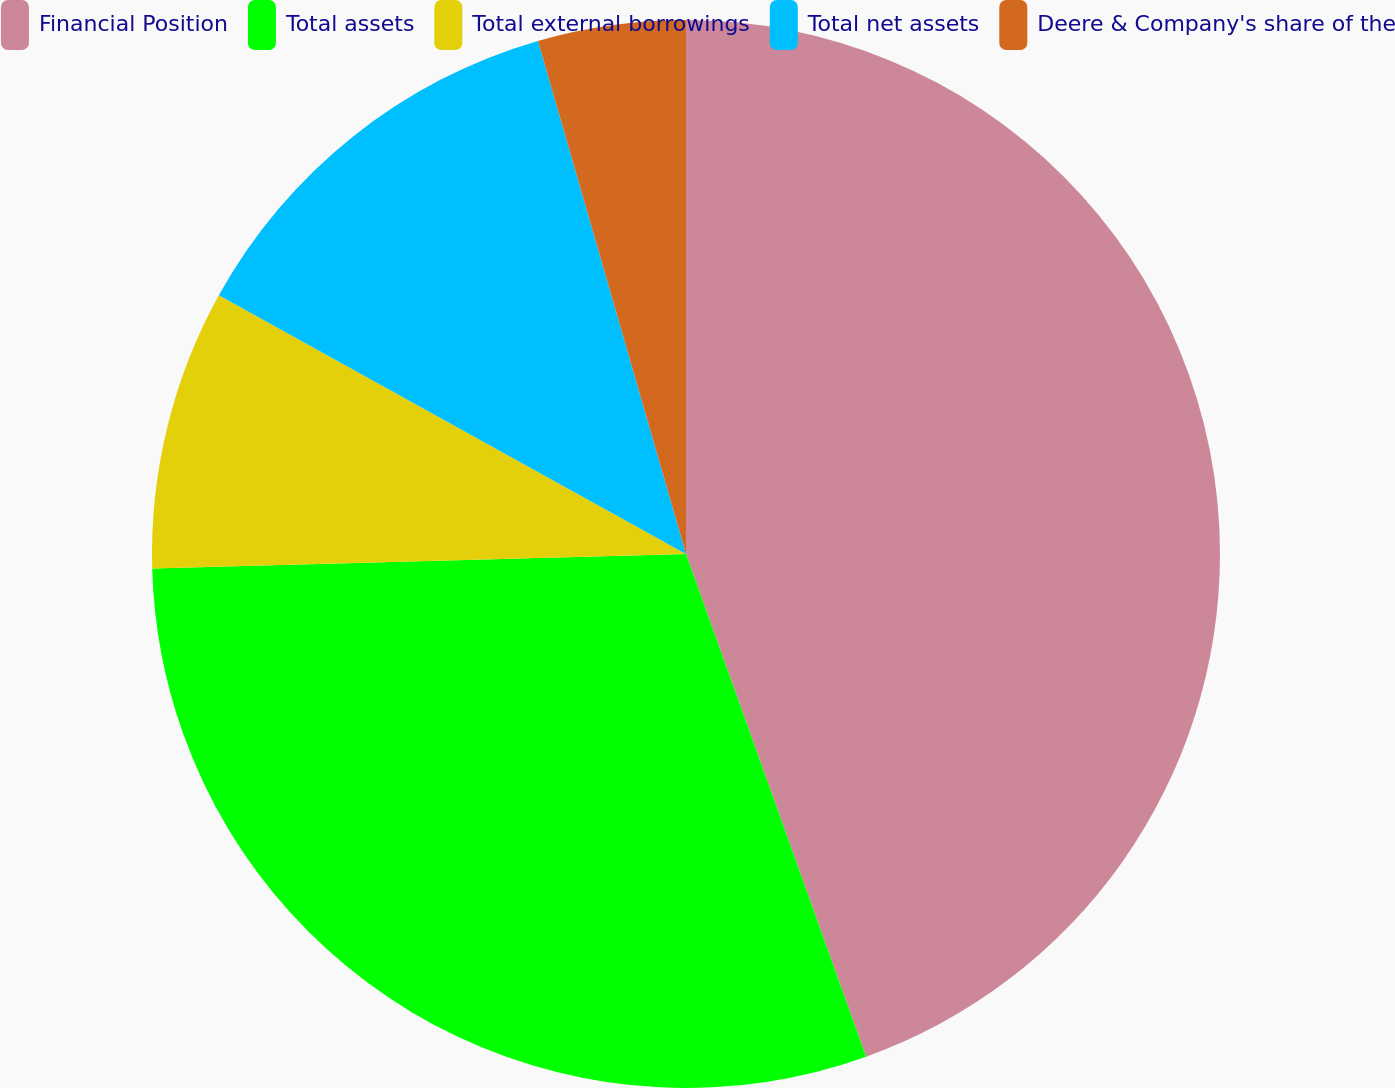<chart> <loc_0><loc_0><loc_500><loc_500><pie_chart><fcel>Financial Position<fcel>Total assets<fcel>Total external borrowings<fcel>Total net assets<fcel>Deere & Company's share of the<nl><fcel>44.52%<fcel>30.04%<fcel>8.48%<fcel>12.48%<fcel>4.47%<nl></chart> 